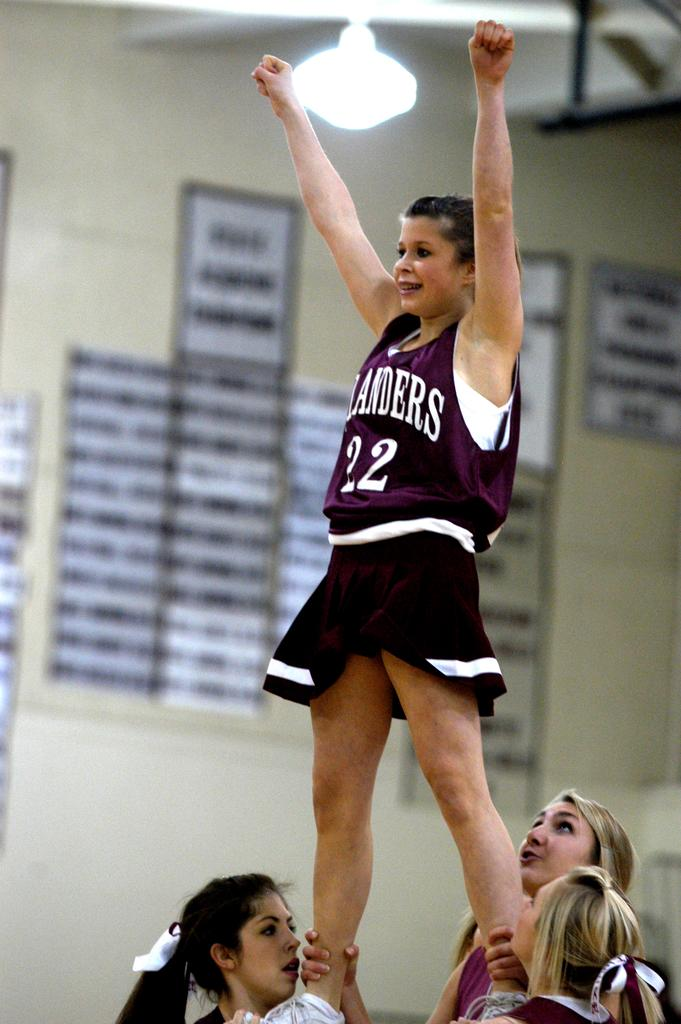<image>
Relay a brief, clear account of the picture shown. A cheerleader wearing the number 22 is being held up by other girls. 